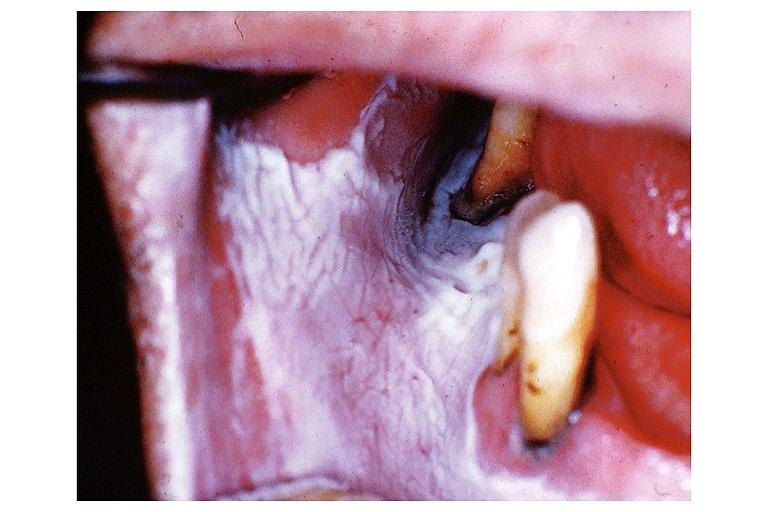does metastatic adenocarcinoma show leukoplakia?
Answer the question using a single word or phrase. No 